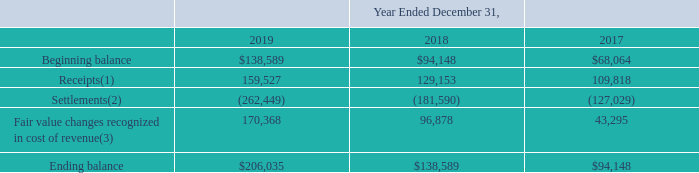ITEM 7. MANAGEMENT'S DISCUSSION AND ANALYSIS OF FINANCIAL CONDITION AND RESULTS OF OPERATIONS (United States Dollars in thousands, except per share data and unless otherwise indicated)
Fair value change in FCR liability
The following table reconciles the beginning and ending measurements of our FCR liability and highlights the activity that drove the fair value change in FCR liability included in our cost of revenue.
(1) Includes: (i) incentive payments from Bank Partners, which is the surplus of finance charges billed to borrowers over an agreedupon portfolio yield, a fixed servicing fee and realized net credit losses, (ii) cash received from recoveries on previously charged-off Bank Partner loans, and (iii) the proceeds received from transferring our rights to Charged-Off Receivables (as defined below) attributable to previously charged-off Bank Partner loans. We consider all monthly incentive payments from Bank Partners during the period to be related to billed finance charges on deferred interest products until monthly incentive payments exceed total billed finance charges on deferred products, which did not occur during any of the periods presented.
(2) Represents the reversal of previously billed finance charges associated with deferred payment loan principal balances that were repaid within the promotional period.
(3) A fair value adjustment is made based on the expected reversal percentage of billed finance charges (expected settlements), which is estimated at each reporting date. The fair value adjustment is recognized in cost of revenue in the Consolidated Statements of Operations.
Which years does the table provide? 2019, 2018, 2017. What was the amount of Receipts in 2017?
Answer scale should be: thousand. 109,818. What was the amount of Settlements in 2019?
Answer scale should be: thousand. (262,449). How many years did the Fair value changes recognized in cost of revenue exceed $100,000 thousand? 2019
Answer: 1. What was the change in the amount of Settlements between 2017 and 2019?
Answer scale should be: thousand. -262,449-(-127,029)
Answer: -135420. What was the percentage change in the ending balance between 2017 and 2018?
Answer scale should be: percent. (138,589-94,148)/94,148
Answer: 47.2. GreenSky, Inc. NOTES TO CONSOLIDATED FINANCIAL STATEMENTS — (Continued) (United States Dollars in thousands, except per share data, unless otherwise stated)
Finance charge reversal liability
Our Bank Partners offer certain loan products that have a feature whereby the account holder is provided a promotional period to repay the loan principal balance in full without incurring a finance charge. For these loan products, we bill interest each month throughout the promotional period and, under the terms of the contracts with our Bank Partners, we are obligated to pay this billed interest to the Bank Partners if an account holder repays the loan balance in full within the promotional period. Therefore, the monthly process of billing interest on deferred loan products triggers a potential future finance charge reversal ("FCR") liability for the Company. The FCR component of our Bank Partner contracts qualifies as an embedded derivative. The FCR liability is not designated as a hedge for accounting purposes and, as such, changes in its fair value are recorded within cost of revenue in the Consolidated Statements of Operations.
The FCR liability is carried at fair value on a recurring basis in the Consolidated Balance Sheets and is estimated based on historical experience and management’s expectation of future FCR. The FCR liability is classified within Level 3 of the fair value hierarchy, as the primary component of the fair value is obtained from unobservable inputs based on the Company’s data, reasonably adjusted for assumptions that would be used by market participants. The following table reconciles the beginning and ending fair value measurements of our FCR liability during the periods indicated.
(1) Includes: (i) incentive payments from Bank Partners, which is the surplus of finance charges billed to borrowers over an agreedupon portfolio yield, a fixed servicing fee and realized net credit losses, (ii) cash received from recoveries on previously charged-off Bank Partner loans, and (iii) the proceeds received from transferring our rights to Charged-Off Receivables attributable to previously charged-off Bank Partner loans. We consider all monthly incentive payments from Bank Partners during the period to be related to billed finance charges on deferred interest products until monthly incentive payments exceed total billed finance charges on deferred products, which did not occur during any of the periods presented.
(2) Represents the reversal of previously billed finance charges associated with deferred payment loan principal balances that were repaid within the promotional period.
(3) A fair value adjustment is made based on the expected reversal percentage of billed finance charges (expected settlements), which is estimated at each reporting date. The fair value adjustment is recognized in cost of revenue in the Consolidated Statements of Operations.
What does the amount of Settlements represent? The reversal of previously billed finance charges associated with deferred payment loan principal balances that were repaid within the promotional period. How was the fair value adjustment made for the fair value changes recognized in cost of revenue? Based on the expected reversal percentage of billed finance charges (expected settlements), which is estimated at each reporting date. Which years does the table show? 2019, 2018, 2017. How many years did the fair value changes exceed $100,000 thousand? 2019
Answer: 1. What was the change in the settlements between 2017 and 2018?
Answer scale should be: thousand. -181,590-(-127,029)
Answer: -54561. What was the percentage change in the ending balance between 2018 and 2019?
Answer scale should be: percent. (206,035-138,589)/138,589
Answer: 48.67. 